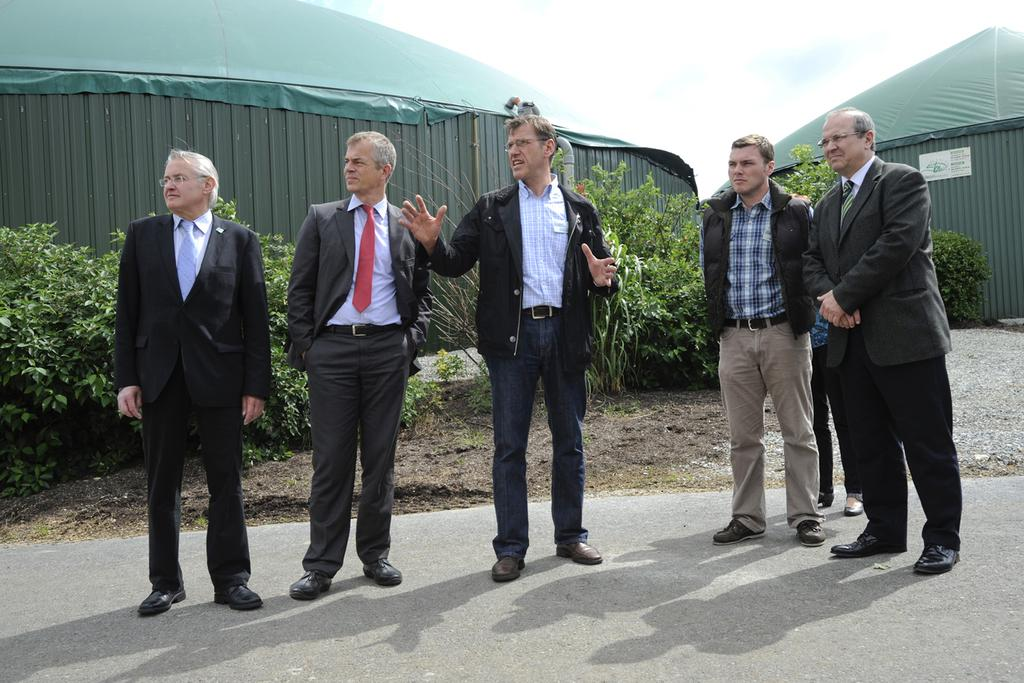What are the men in the image doing? The men in the image are standing on the surface of the road. What can be seen in the image besides the men? There are plants visible in the image. What is located behind the plants? There are tents behind the plants. What type of patch is sewn onto the men's clothing in the image? There is no mention of patches on the men's clothing in the image, so it cannot be determined from the provided facts. 